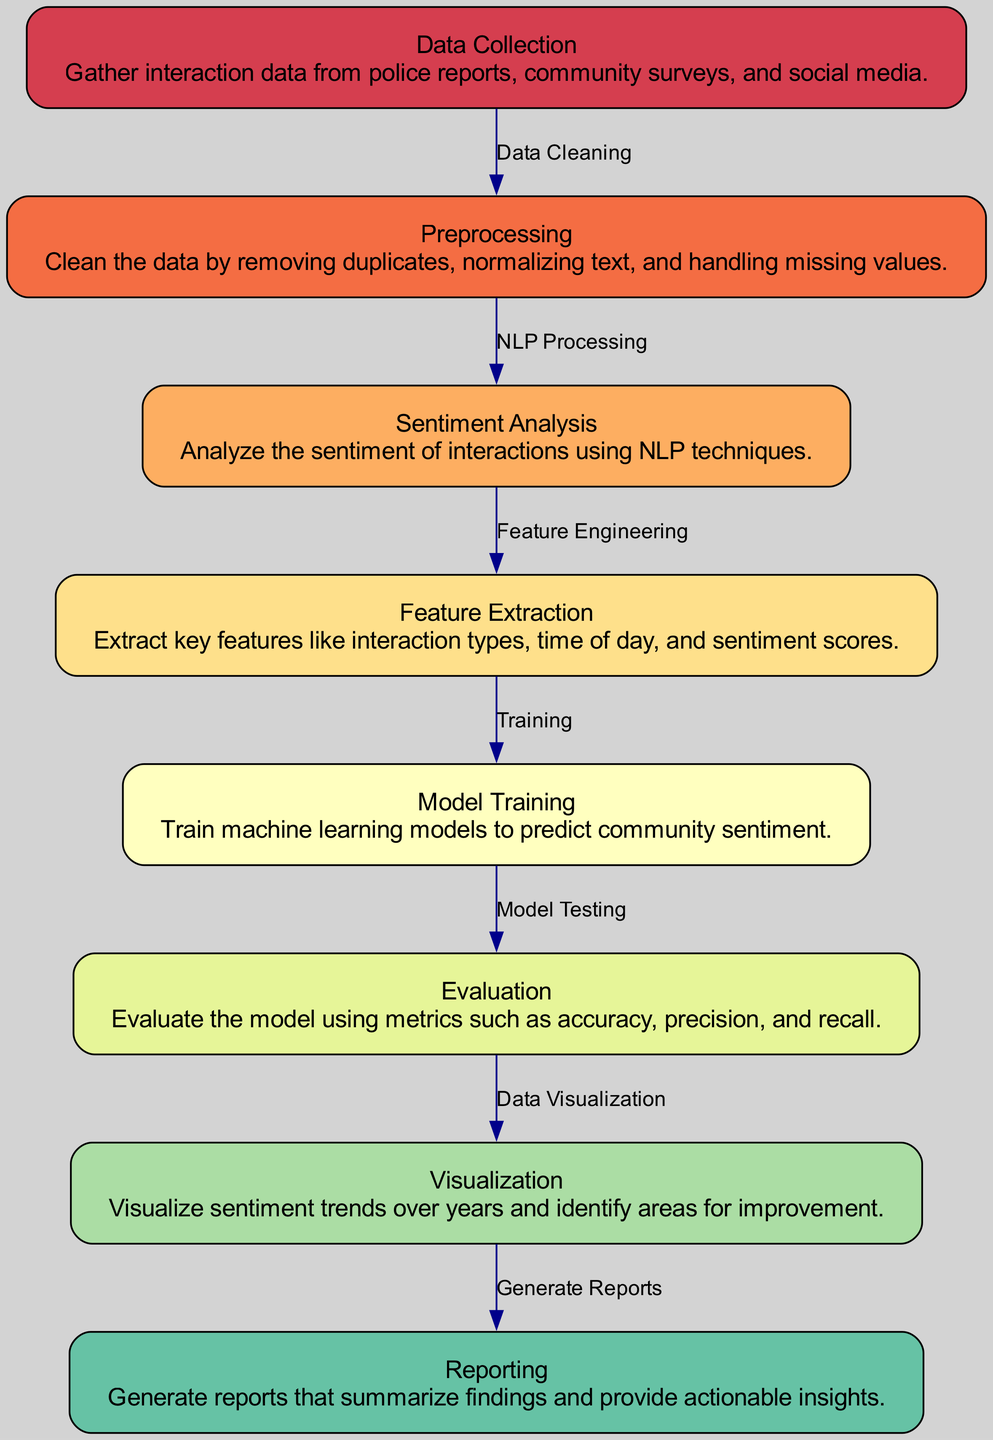What is the first step in the process? The first step is "Data Collection," which involves gathering interaction data from various sources such as police reports and community surveys.
Answer: Data Collection How many nodes are in the diagram? By counting each labeled node in the diagram, there are a total of eight nodes.
Answer: Eight What is the last step before generating reports? The last step before generating reports is "Visualization," which visualizes sentiment trends and identifies areas for improvement.
Answer: Visualization Which process follows "Model Training"? After "Model Training," the next process is "Evaluation," where the model's performance is assessed using various metrics.
Answer: Evaluation What type of analysis is performed on the data? The type of analysis performed on the data is "Sentiment Analysis," which uses natural language processing techniques to analyze community interactions.
Answer: Sentiment Analysis What connects "Feature Extraction" and "Model Training"? The connection between "Feature Extraction" and "Model Training" is labeled as "Training," indicating that the extracted features are used to train the machine learning models.
Answer: Training Which node describes selecting key aspects of interactions? The node that describes selecting key aspects of interactions is "Feature Extraction," which focuses on key features such as interaction types and sentiment scores.
Answer: Feature Extraction What is evaluated to measure model performance? The evaluation measures model performance using metrics such as accuracy, precision, and recall, as part of the "Evaluation" step.
Answer: Metrics What is a major source of interaction data mentioned? A major source of interaction data mentioned in the diagram is "social media," which is part of the "Data Collection" process.
Answer: Social media 